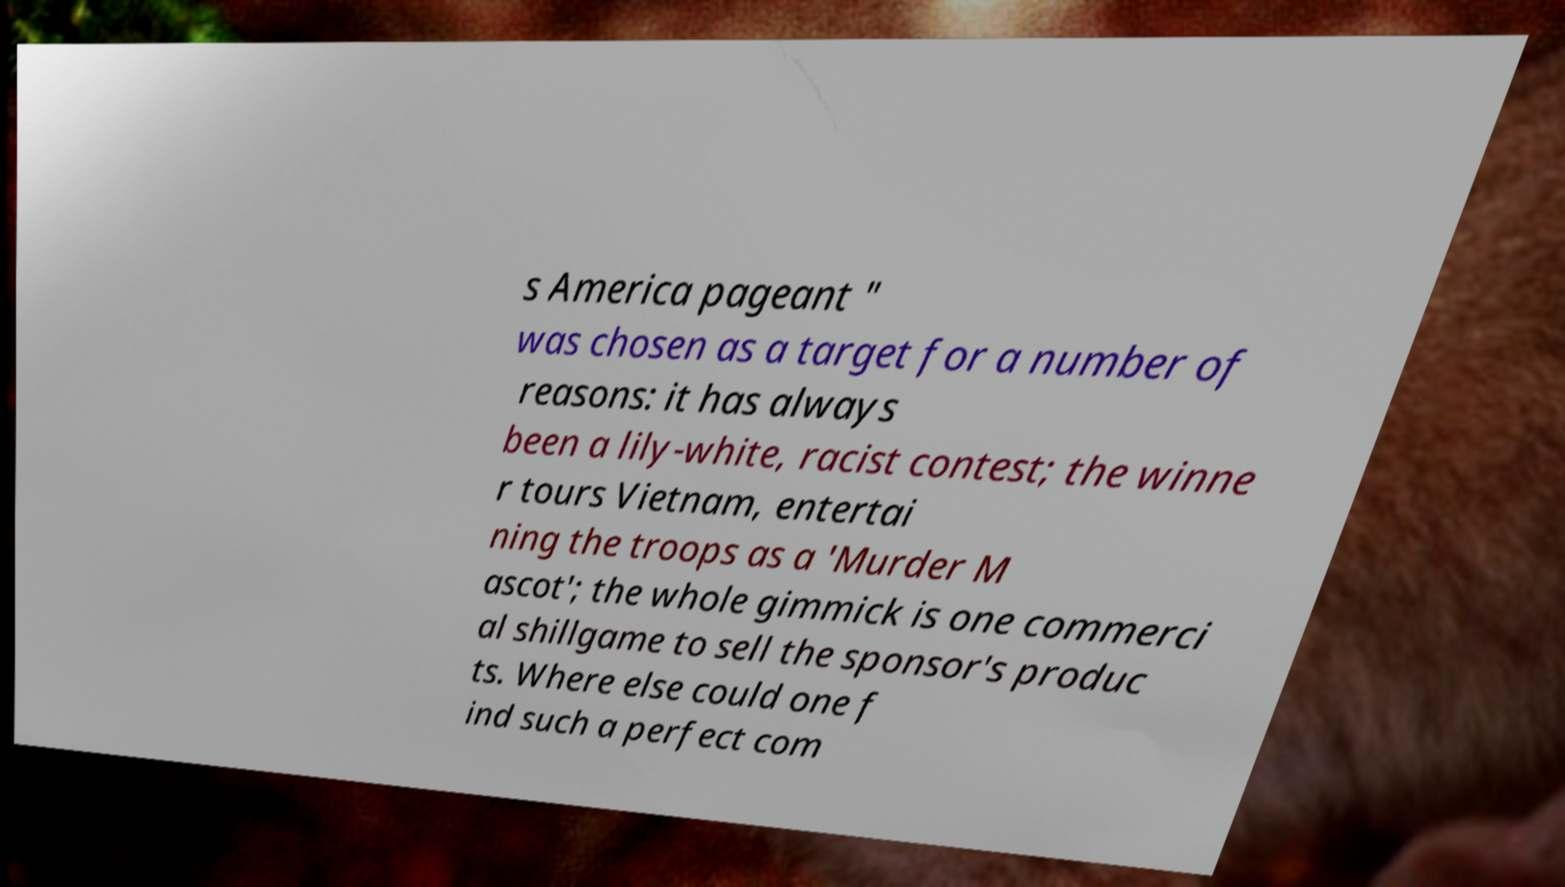There's text embedded in this image that I need extracted. Can you transcribe it verbatim? s America pageant " was chosen as a target for a number of reasons: it has always been a lily-white, racist contest; the winne r tours Vietnam, entertai ning the troops as a 'Murder M ascot'; the whole gimmick is one commerci al shillgame to sell the sponsor's produc ts. Where else could one f ind such a perfect com 